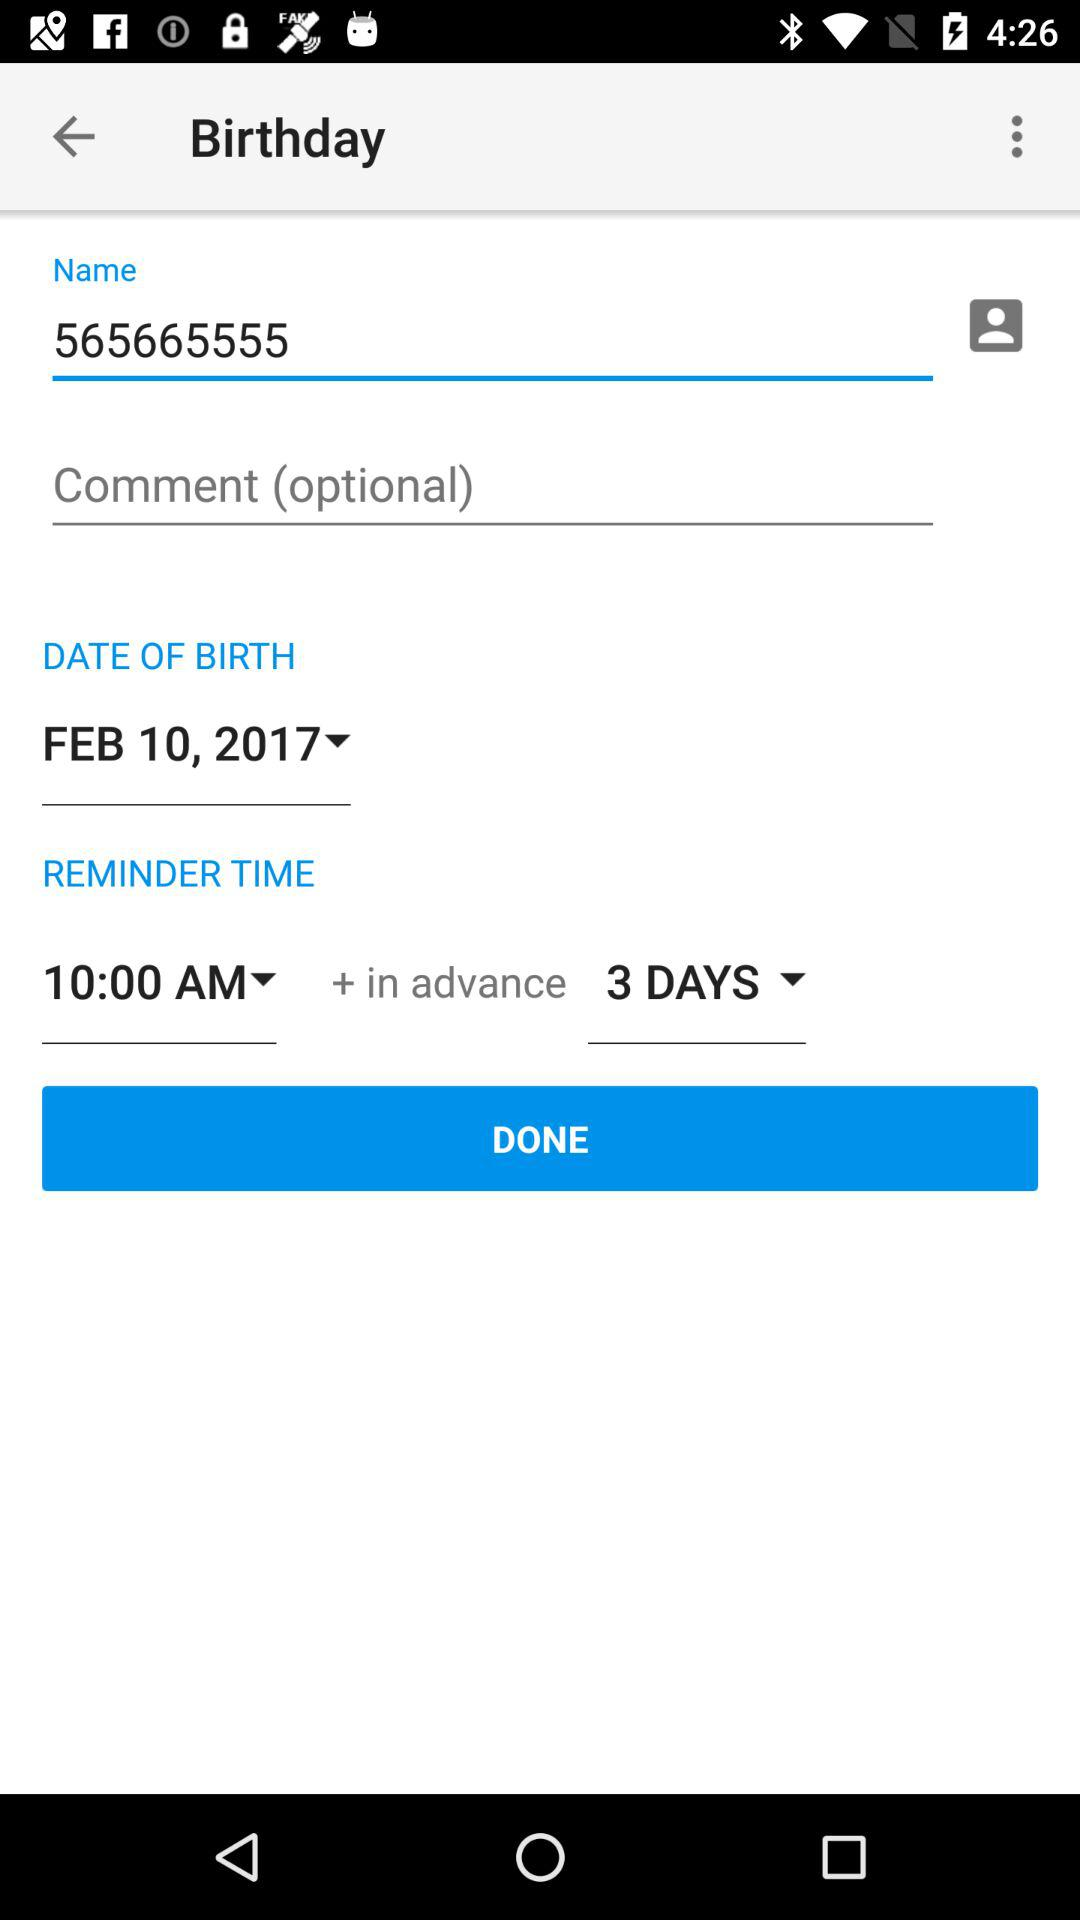How many days in advance does the reminder have to be given? The reminder has to be given 3 days in advance. 